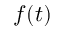Convert formula to latex. <formula><loc_0><loc_0><loc_500><loc_500>f ( t )</formula> 